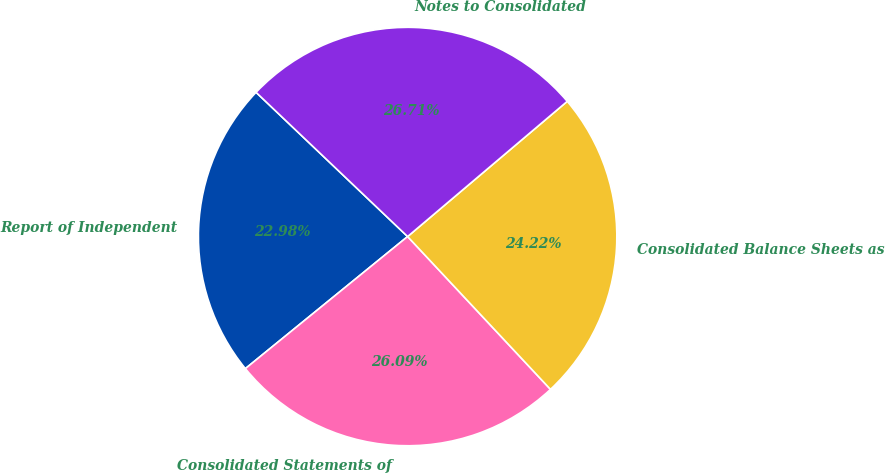Convert chart to OTSL. <chart><loc_0><loc_0><loc_500><loc_500><pie_chart><fcel>Report of Independent<fcel>Consolidated Statements of<fcel>Consolidated Balance Sheets as<fcel>Notes to Consolidated<nl><fcel>22.98%<fcel>26.09%<fcel>24.22%<fcel>26.71%<nl></chart> 